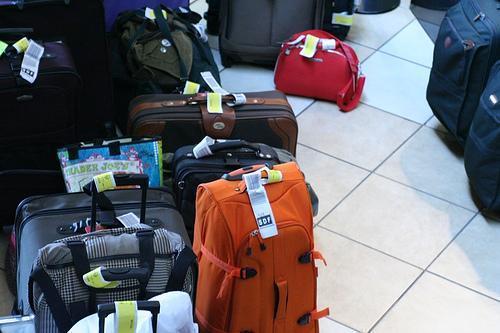How many pieces are there?
Give a very brief answer. 14. 